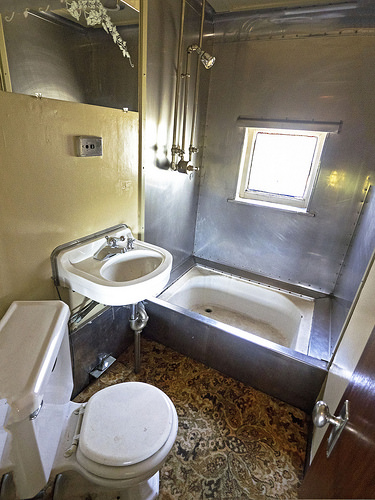<image>
Can you confirm if the tub is next to the toilet? No. The tub is not positioned next to the toilet. They are located in different areas of the scene. 